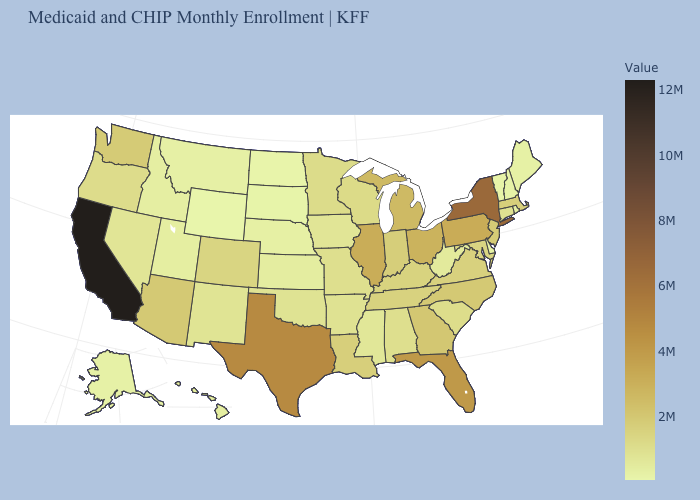Among the states that border Mississippi , does Arkansas have the lowest value?
Give a very brief answer. Yes. Does the map have missing data?
Quick response, please. No. Among the states that border Massachusetts , which have the lowest value?
Write a very short answer. Vermont. Among the states that border Tennessee , which have the highest value?
Short answer required. Georgia. Does Texas have the highest value in the South?
Give a very brief answer. Yes. 